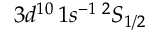Convert formula to latex. <formula><loc_0><loc_0><loc_500><loc_500>3 d ^ { 1 0 } \, 1 s ^ { - 1 } \, ^ { 2 } S _ { 1 / 2 }</formula> 